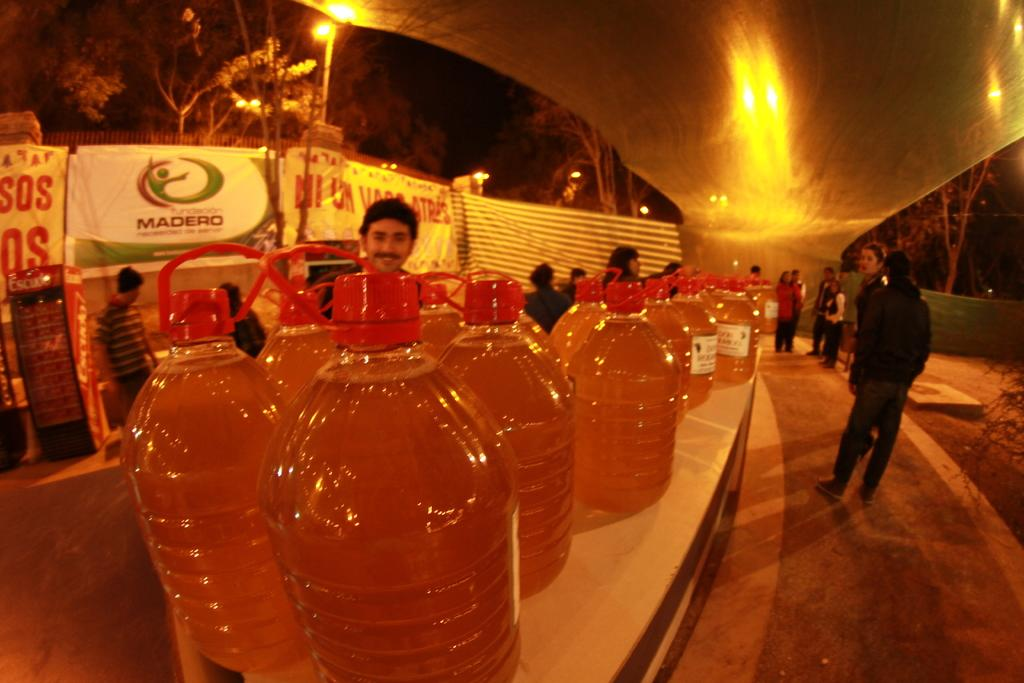<image>
Summarize the visual content of the image. large jugs of amber colored substances in front of Madero sign 